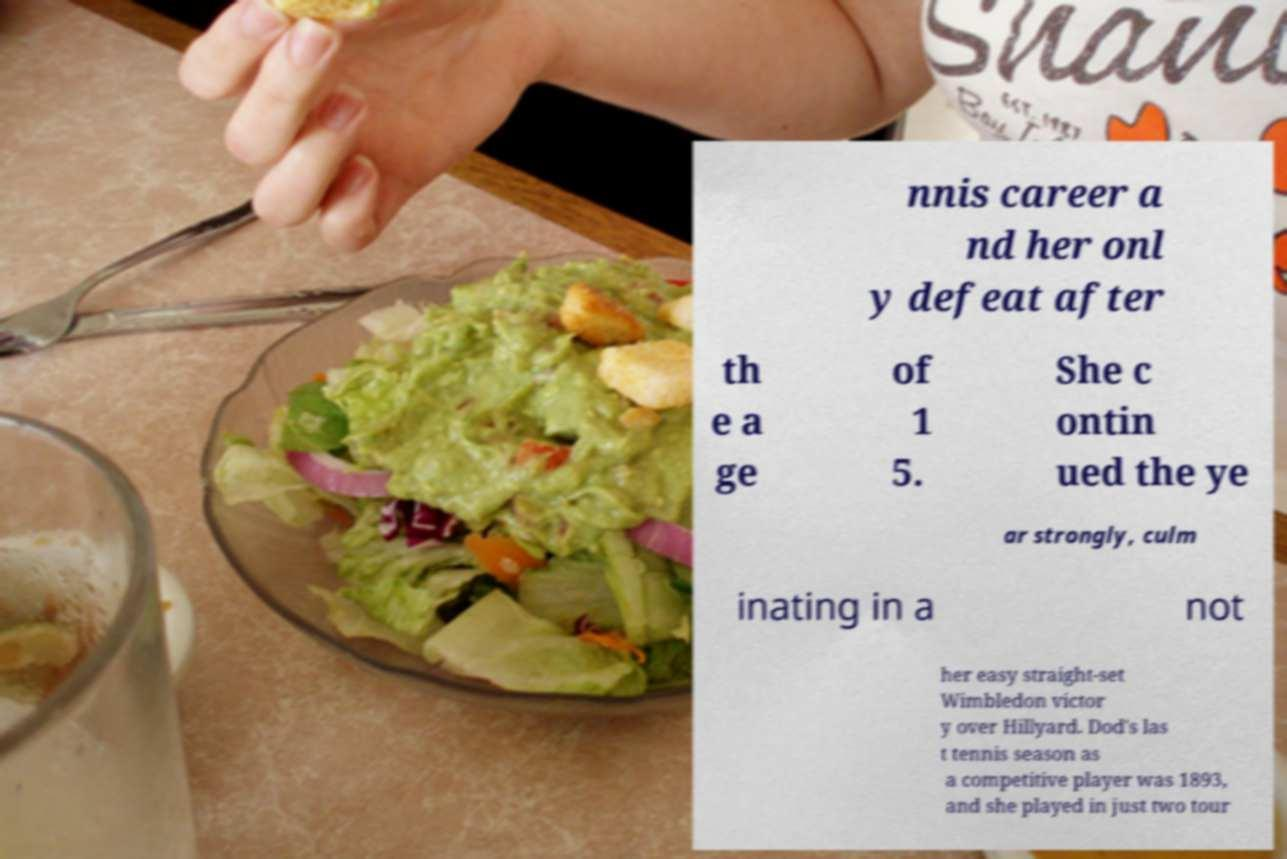What messages or text are displayed in this image? I need them in a readable, typed format. nnis career a nd her onl y defeat after th e a ge of 1 5. She c ontin ued the ye ar strongly, culm inating in a not her easy straight-set Wimbledon victor y over Hillyard. Dod's las t tennis season as a competitive player was 1893, and she played in just two tour 